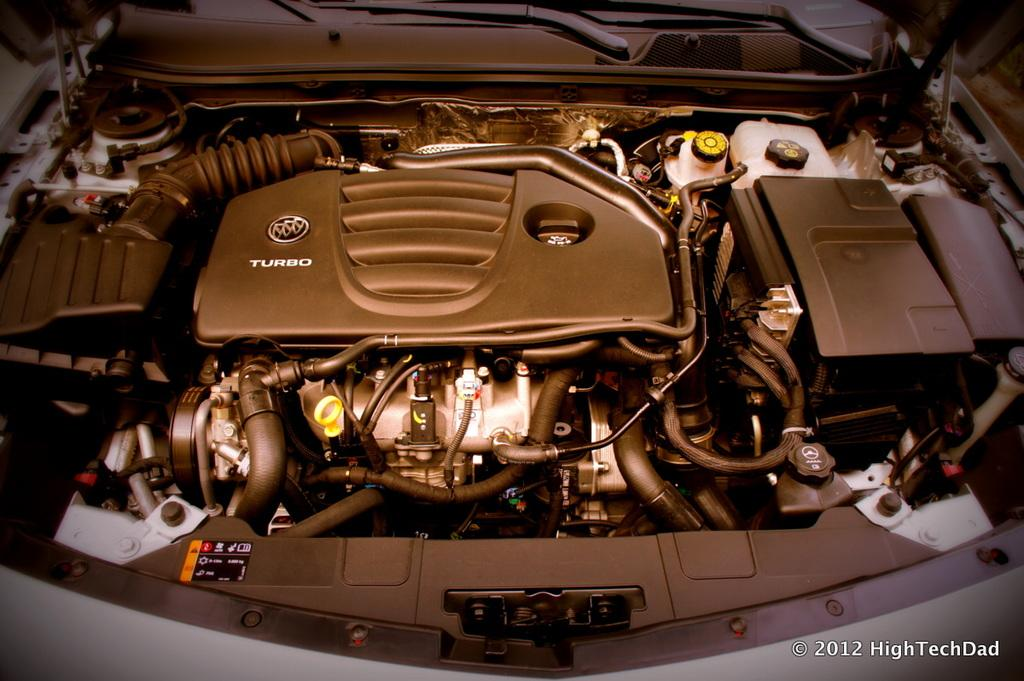<image>
Present a compact description of the photo's key features. Copyrighted in 2012 to High Tech Dad is a photo of a turbo, Buick image. 